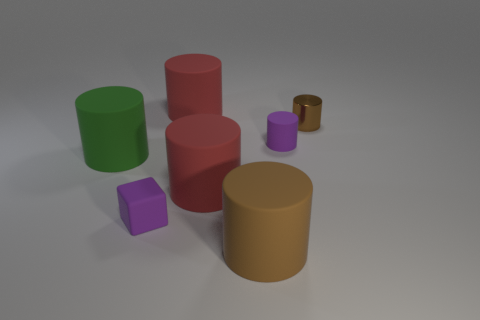Is there any other thing that has the same material as the purple cube?
Your response must be concise. Yes. How many things are large green cylinders or red cylinders in front of the metal object?
Your answer should be very brief. 2. There is a rubber cylinder on the right side of the brown rubber cylinder; is it the same size as the large green object?
Give a very brief answer. No. How many other things are there of the same shape as the tiny brown object?
Offer a terse response. 5. How many purple things are either tiny matte spheres or small metallic things?
Provide a succinct answer. 0. Does the big rubber cylinder that is behind the big green matte object have the same color as the cube?
Ensure brevity in your answer.  No. There is a small thing that is the same material as the purple cylinder; what is its shape?
Keep it short and to the point. Cube. There is a cylinder that is left of the brown rubber thing and behind the big green matte cylinder; what color is it?
Your answer should be very brief. Red. There is a purple thing that is to the right of the big red cylinder in front of the brown metallic thing; what size is it?
Your answer should be compact. Small. Are there any small objects that have the same color as the small metal cylinder?
Ensure brevity in your answer.  No. 